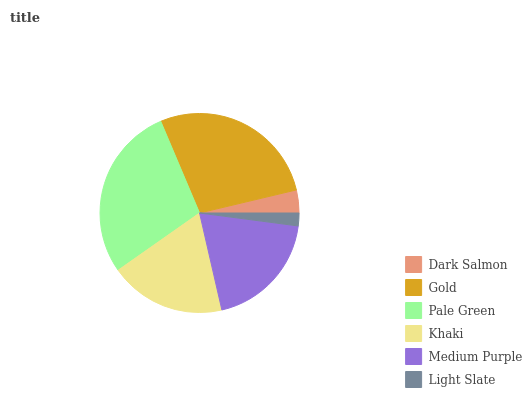Is Light Slate the minimum?
Answer yes or no. Yes. Is Pale Green the maximum?
Answer yes or no. Yes. Is Gold the minimum?
Answer yes or no. No. Is Gold the maximum?
Answer yes or no. No. Is Gold greater than Dark Salmon?
Answer yes or no. Yes. Is Dark Salmon less than Gold?
Answer yes or no. Yes. Is Dark Salmon greater than Gold?
Answer yes or no. No. Is Gold less than Dark Salmon?
Answer yes or no. No. Is Medium Purple the high median?
Answer yes or no. Yes. Is Khaki the low median?
Answer yes or no. Yes. Is Khaki the high median?
Answer yes or no. No. Is Dark Salmon the low median?
Answer yes or no. No. 